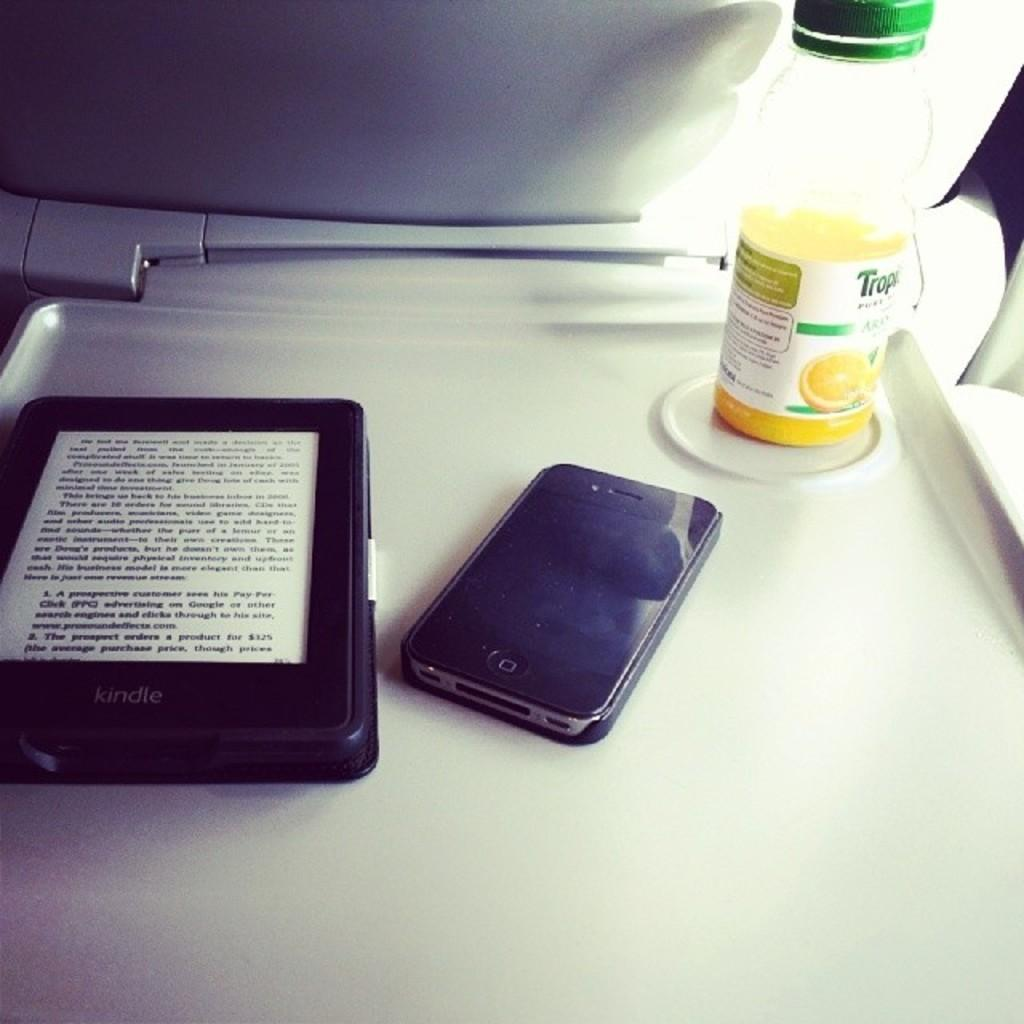<image>
Relay a brief, clear account of the picture shown. Tray table that shows a kindle with a book to the left and to the right is a older I phone sitting next to a single serving of Orange juice. 